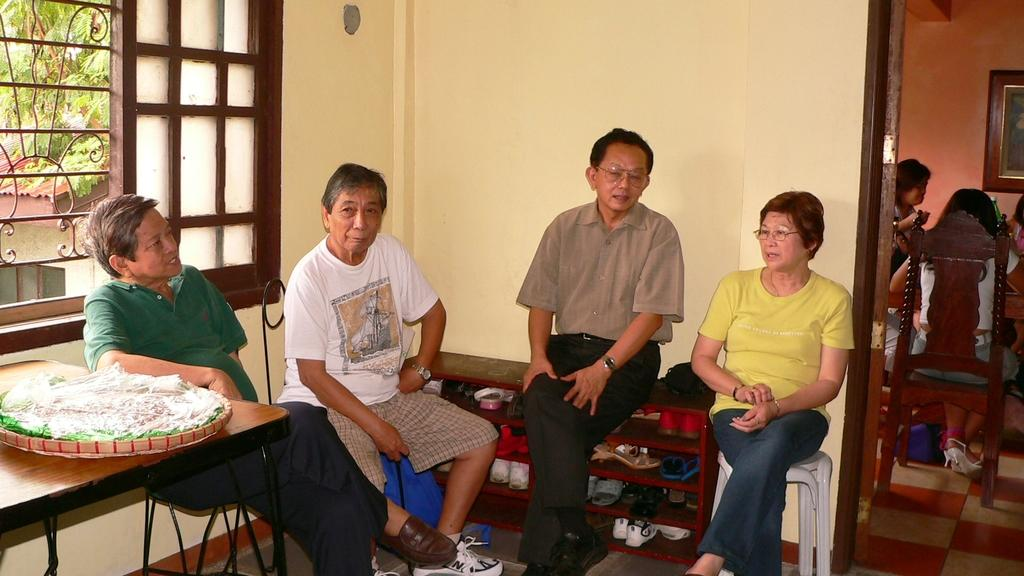What type of structure can be seen in the image? There is a wall in the image. What architectural feature is present in the wall? There is a window in the image. What type of furniture is visible in the image? There are tables and chairs in the image. What are the people in the image doing? There are people sitting in the image. What type of decorative item is present in the image? There is a photo frame in the image. What type of personal belongings can be seen in the image? There are footwear's in the image. What can be seen outside the window in the image? Outside the window, there is a house and a tree in the image. What type of banana is being used as a caption for the photo frame in the image? There is no banana present in the image, nor is it being used as a caption for the photo frame. 